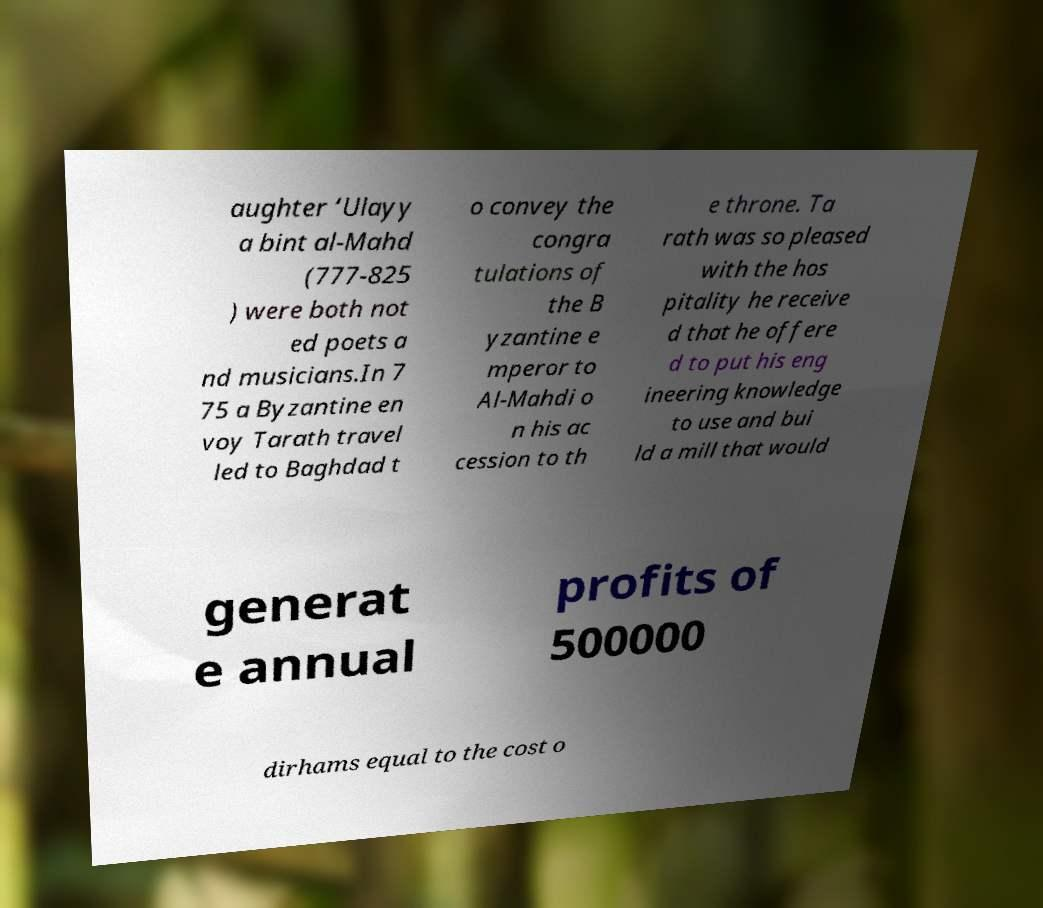I need the written content from this picture converted into text. Can you do that? aughter ‘Ulayy a bint al-Mahd (777-825 ) were both not ed poets a nd musicians.In 7 75 a Byzantine en voy Tarath travel led to Baghdad t o convey the congra tulations of the B yzantine e mperor to Al-Mahdi o n his ac cession to th e throne. Ta rath was so pleased with the hos pitality he receive d that he offere d to put his eng ineering knowledge to use and bui ld a mill that would generat e annual profits of 500000 dirhams equal to the cost o 